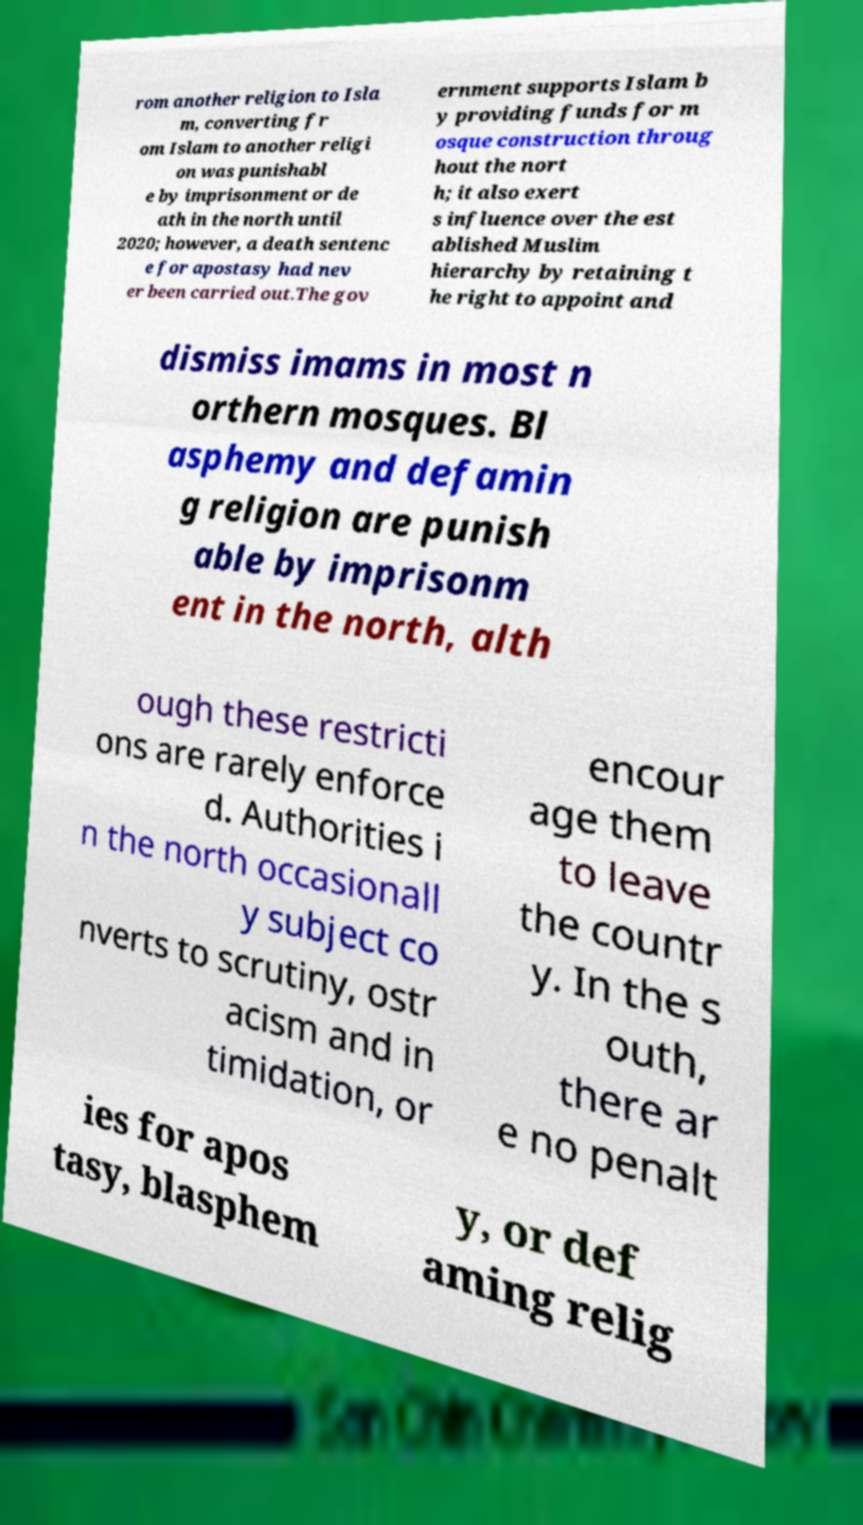There's text embedded in this image that I need extracted. Can you transcribe it verbatim? rom another religion to Isla m, converting fr om Islam to another religi on was punishabl e by imprisonment or de ath in the north until 2020; however, a death sentenc e for apostasy had nev er been carried out.The gov ernment supports Islam b y providing funds for m osque construction throug hout the nort h; it also exert s influence over the est ablished Muslim hierarchy by retaining t he right to appoint and dismiss imams in most n orthern mosques. Bl asphemy and defamin g religion are punish able by imprisonm ent in the north, alth ough these restricti ons are rarely enforce d. Authorities i n the north occasionall y subject co nverts to scrutiny, ostr acism and in timidation, or encour age them to leave the countr y. In the s outh, there ar e no penalt ies for apos tasy, blasphem y, or def aming relig 